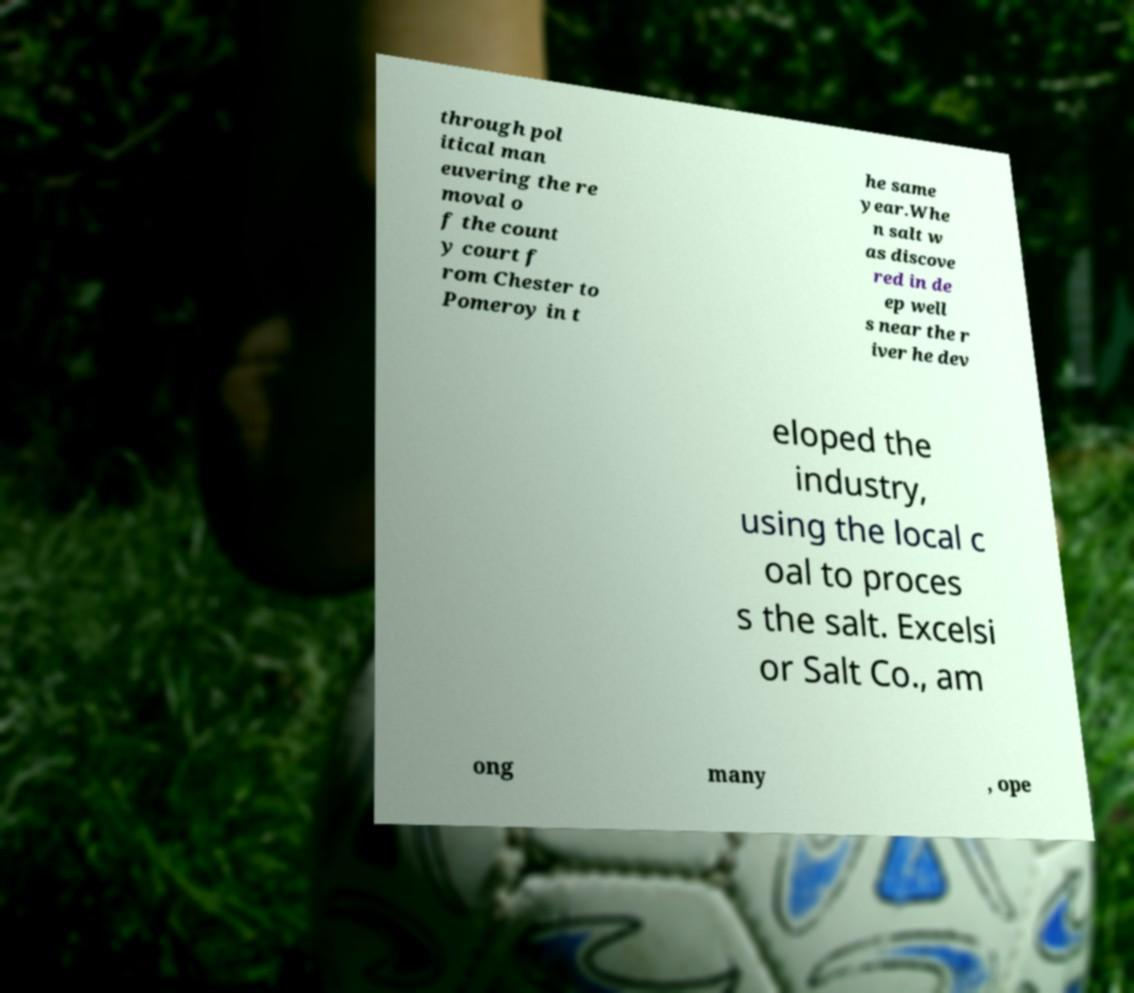Could you extract and type out the text from this image? through pol itical man euvering the re moval o f the count y court f rom Chester to Pomeroy in t he same year.Whe n salt w as discove red in de ep well s near the r iver he dev eloped the industry, using the local c oal to proces s the salt. Excelsi or Salt Co., am ong many , ope 